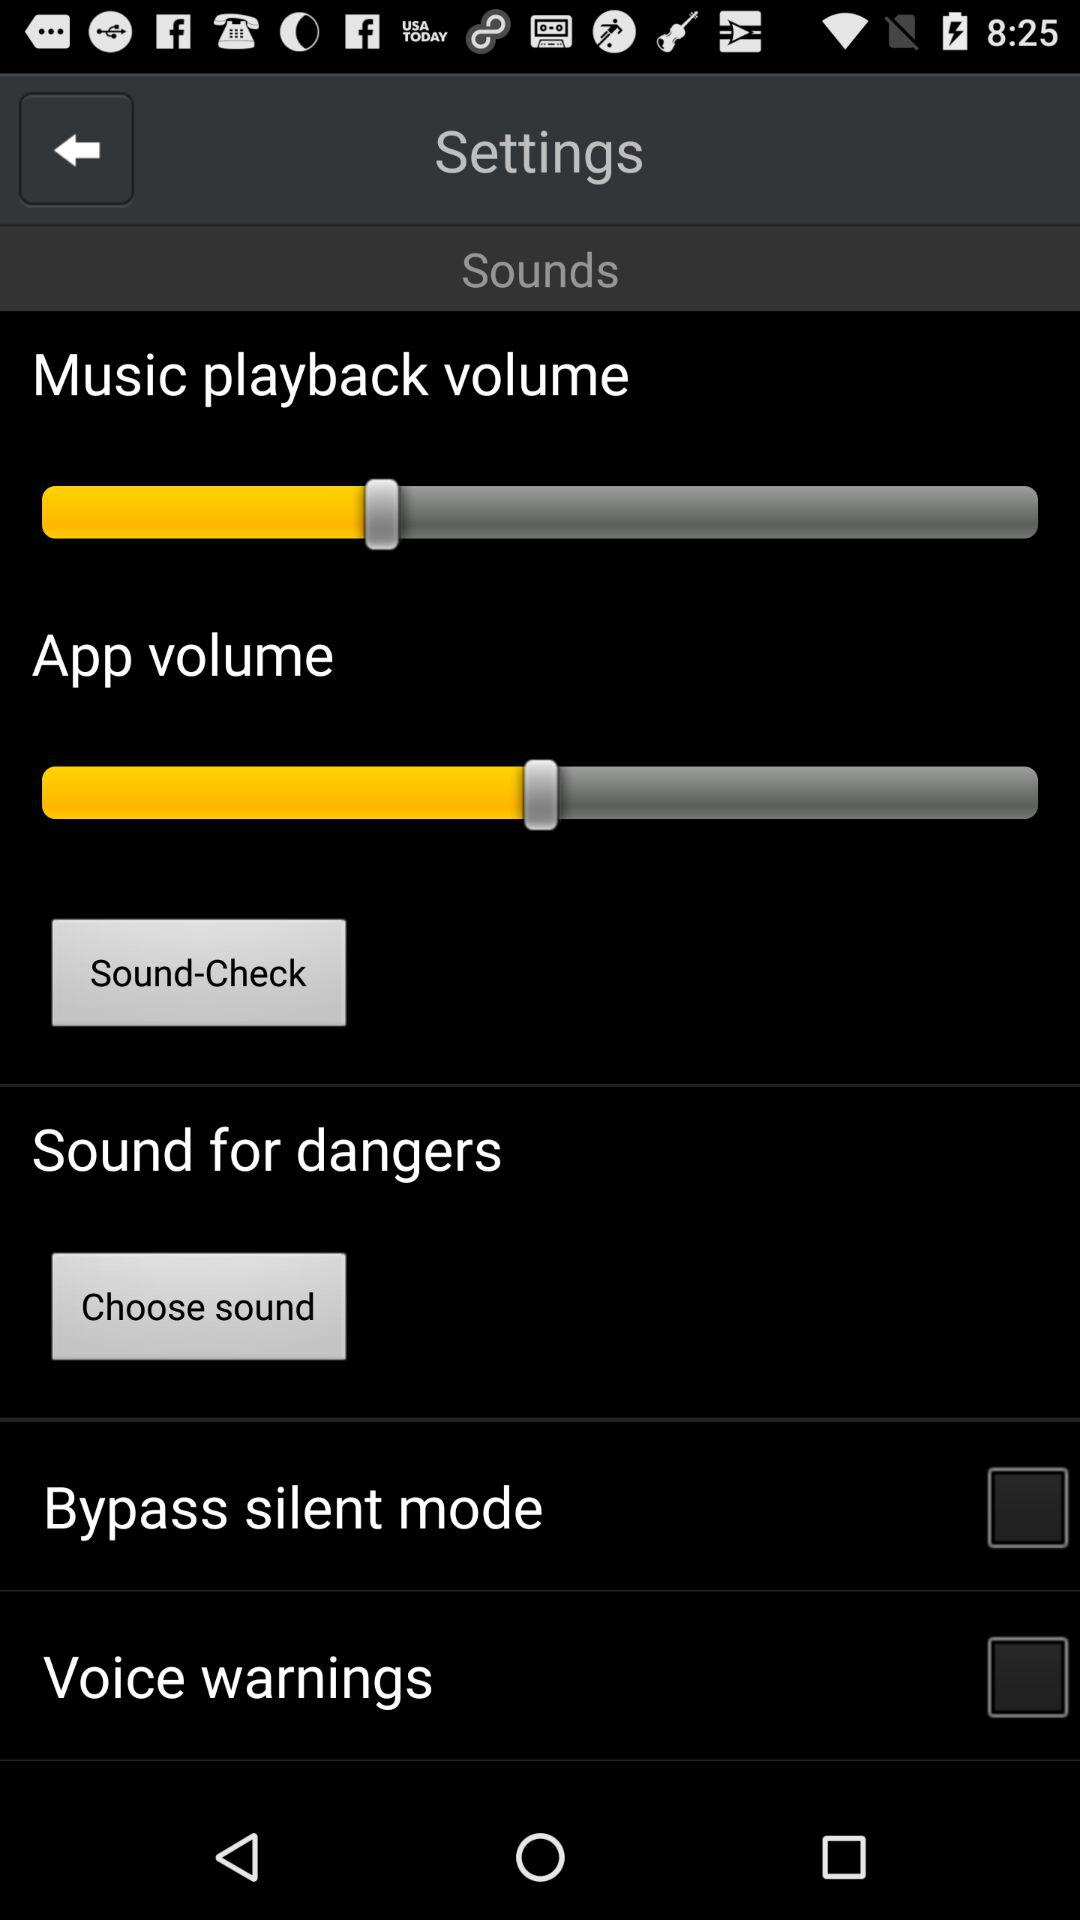What is the current status of "Voice warnings"? The current status is "off". 